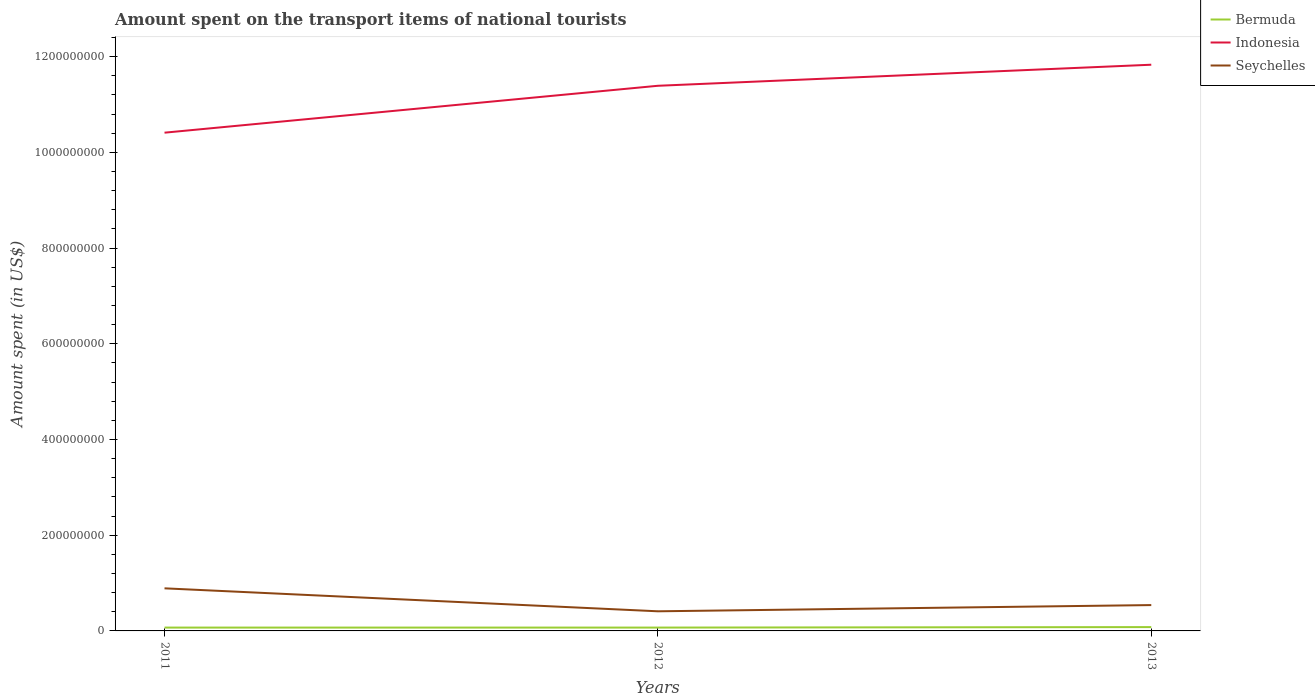How many different coloured lines are there?
Keep it short and to the point. 3. Across all years, what is the maximum amount spent on the transport items of national tourists in Seychelles?
Offer a very short reply. 4.10e+07. In which year was the amount spent on the transport items of national tourists in Indonesia maximum?
Your answer should be compact. 2011. What is the difference between the highest and the second highest amount spent on the transport items of national tourists in Indonesia?
Provide a succinct answer. 1.42e+08. Where does the legend appear in the graph?
Your answer should be compact. Top right. How are the legend labels stacked?
Offer a very short reply. Vertical. What is the title of the graph?
Keep it short and to the point. Amount spent on the transport items of national tourists. What is the label or title of the Y-axis?
Provide a succinct answer. Amount spent (in US$). What is the Amount spent (in US$) in Bermuda in 2011?
Give a very brief answer. 7.00e+06. What is the Amount spent (in US$) of Indonesia in 2011?
Offer a very short reply. 1.04e+09. What is the Amount spent (in US$) of Seychelles in 2011?
Offer a terse response. 8.90e+07. What is the Amount spent (in US$) of Indonesia in 2012?
Your answer should be very brief. 1.14e+09. What is the Amount spent (in US$) of Seychelles in 2012?
Your answer should be very brief. 4.10e+07. What is the Amount spent (in US$) in Indonesia in 2013?
Ensure brevity in your answer.  1.18e+09. What is the Amount spent (in US$) of Seychelles in 2013?
Your answer should be very brief. 5.40e+07. Across all years, what is the maximum Amount spent (in US$) of Indonesia?
Keep it short and to the point. 1.18e+09. Across all years, what is the maximum Amount spent (in US$) in Seychelles?
Offer a terse response. 8.90e+07. Across all years, what is the minimum Amount spent (in US$) of Indonesia?
Provide a short and direct response. 1.04e+09. Across all years, what is the minimum Amount spent (in US$) in Seychelles?
Offer a terse response. 4.10e+07. What is the total Amount spent (in US$) of Bermuda in the graph?
Keep it short and to the point. 2.20e+07. What is the total Amount spent (in US$) in Indonesia in the graph?
Make the answer very short. 3.36e+09. What is the total Amount spent (in US$) in Seychelles in the graph?
Offer a very short reply. 1.84e+08. What is the difference between the Amount spent (in US$) of Indonesia in 2011 and that in 2012?
Give a very brief answer. -9.80e+07. What is the difference between the Amount spent (in US$) of Seychelles in 2011 and that in 2012?
Ensure brevity in your answer.  4.80e+07. What is the difference between the Amount spent (in US$) of Bermuda in 2011 and that in 2013?
Make the answer very short. -1.00e+06. What is the difference between the Amount spent (in US$) in Indonesia in 2011 and that in 2013?
Give a very brief answer. -1.42e+08. What is the difference between the Amount spent (in US$) in Seychelles in 2011 and that in 2013?
Your answer should be compact. 3.50e+07. What is the difference between the Amount spent (in US$) in Bermuda in 2012 and that in 2013?
Offer a very short reply. -1.00e+06. What is the difference between the Amount spent (in US$) of Indonesia in 2012 and that in 2013?
Provide a short and direct response. -4.40e+07. What is the difference between the Amount spent (in US$) of Seychelles in 2012 and that in 2013?
Provide a short and direct response. -1.30e+07. What is the difference between the Amount spent (in US$) in Bermuda in 2011 and the Amount spent (in US$) in Indonesia in 2012?
Your answer should be compact. -1.13e+09. What is the difference between the Amount spent (in US$) in Bermuda in 2011 and the Amount spent (in US$) in Seychelles in 2012?
Offer a very short reply. -3.40e+07. What is the difference between the Amount spent (in US$) of Bermuda in 2011 and the Amount spent (in US$) of Indonesia in 2013?
Give a very brief answer. -1.18e+09. What is the difference between the Amount spent (in US$) in Bermuda in 2011 and the Amount spent (in US$) in Seychelles in 2013?
Your answer should be compact. -4.70e+07. What is the difference between the Amount spent (in US$) in Indonesia in 2011 and the Amount spent (in US$) in Seychelles in 2013?
Offer a terse response. 9.87e+08. What is the difference between the Amount spent (in US$) of Bermuda in 2012 and the Amount spent (in US$) of Indonesia in 2013?
Your answer should be very brief. -1.18e+09. What is the difference between the Amount spent (in US$) in Bermuda in 2012 and the Amount spent (in US$) in Seychelles in 2013?
Provide a short and direct response. -4.70e+07. What is the difference between the Amount spent (in US$) of Indonesia in 2012 and the Amount spent (in US$) of Seychelles in 2013?
Ensure brevity in your answer.  1.08e+09. What is the average Amount spent (in US$) in Bermuda per year?
Your answer should be compact. 7.33e+06. What is the average Amount spent (in US$) in Indonesia per year?
Offer a terse response. 1.12e+09. What is the average Amount spent (in US$) of Seychelles per year?
Your answer should be compact. 6.13e+07. In the year 2011, what is the difference between the Amount spent (in US$) of Bermuda and Amount spent (in US$) of Indonesia?
Your answer should be very brief. -1.03e+09. In the year 2011, what is the difference between the Amount spent (in US$) in Bermuda and Amount spent (in US$) in Seychelles?
Your answer should be very brief. -8.20e+07. In the year 2011, what is the difference between the Amount spent (in US$) of Indonesia and Amount spent (in US$) of Seychelles?
Make the answer very short. 9.52e+08. In the year 2012, what is the difference between the Amount spent (in US$) of Bermuda and Amount spent (in US$) of Indonesia?
Offer a very short reply. -1.13e+09. In the year 2012, what is the difference between the Amount spent (in US$) in Bermuda and Amount spent (in US$) in Seychelles?
Provide a short and direct response. -3.40e+07. In the year 2012, what is the difference between the Amount spent (in US$) in Indonesia and Amount spent (in US$) in Seychelles?
Keep it short and to the point. 1.10e+09. In the year 2013, what is the difference between the Amount spent (in US$) in Bermuda and Amount spent (in US$) in Indonesia?
Provide a succinct answer. -1.18e+09. In the year 2013, what is the difference between the Amount spent (in US$) of Bermuda and Amount spent (in US$) of Seychelles?
Ensure brevity in your answer.  -4.60e+07. In the year 2013, what is the difference between the Amount spent (in US$) of Indonesia and Amount spent (in US$) of Seychelles?
Ensure brevity in your answer.  1.13e+09. What is the ratio of the Amount spent (in US$) in Bermuda in 2011 to that in 2012?
Your response must be concise. 1. What is the ratio of the Amount spent (in US$) of Indonesia in 2011 to that in 2012?
Your response must be concise. 0.91. What is the ratio of the Amount spent (in US$) of Seychelles in 2011 to that in 2012?
Keep it short and to the point. 2.17. What is the ratio of the Amount spent (in US$) in Bermuda in 2011 to that in 2013?
Your answer should be compact. 0.88. What is the ratio of the Amount spent (in US$) in Seychelles in 2011 to that in 2013?
Provide a succinct answer. 1.65. What is the ratio of the Amount spent (in US$) in Indonesia in 2012 to that in 2013?
Your answer should be very brief. 0.96. What is the ratio of the Amount spent (in US$) of Seychelles in 2012 to that in 2013?
Your answer should be very brief. 0.76. What is the difference between the highest and the second highest Amount spent (in US$) in Bermuda?
Offer a very short reply. 1.00e+06. What is the difference between the highest and the second highest Amount spent (in US$) of Indonesia?
Your answer should be very brief. 4.40e+07. What is the difference between the highest and the second highest Amount spent (in US$) of Seychelles?
Give a very brief answer. 3.50e+07. What is the difference between the highest and the lowest Amount spent (in US$) in Bermuda?
Offer a very short reply. 1.00e+06. What is the difference between the highest and the lowest Amount spent (in US$) of Indonesia?
Give a very brief answer. 1.42e+08. What is the difference between the highest and the lowest Amount spent (in US$) of Seychelles?
Provide a succinct answer. 4.80e+07. 